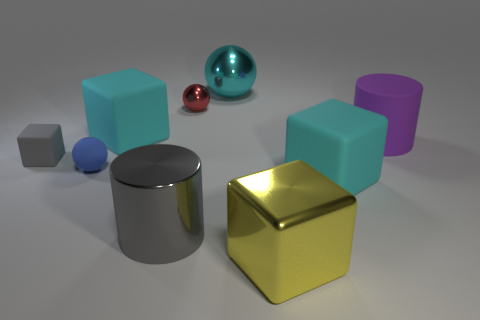There is a big rubber thing that is left of the cyan metallic thing; does it have the same color as the large matte thing in front of the blue object?
Give a very brief answer. Yes. What is the material of the cylinder that is the same color as the small block?
Offer a very short reply. Metal. There is a gray thing that is behind the tiny blue rubber object; does it have the same size as the gray object to the right of the rubber ball?
Your answer should be very brief. No. There is a cyan object that is left of the red shiny ball; what is its shape?
Ensure brevity in your answer.  Cube. What is the material of the cyan object that is the same shape as the small red metal thing?
Offer a very short reply. Metal. Do the matte cube to the right of the red metallic object and the large purple object have the same size?
Your answer should be very brief. Yes. What number of matte blocks are on the right side of the tiny blue object?
Offer a very short reply. 2. Is the number of shiny cylinders behind the small blue sphere less than the number of small gray matte cubes that are on the right side of the metal cylinder?
Offer a very short reply. No. How many large shiny cubes are there?
Your answer should be very brief. 1. What color is the block on the right side of the big yellow metallic thing?
Your response must be concise. Cyan. 